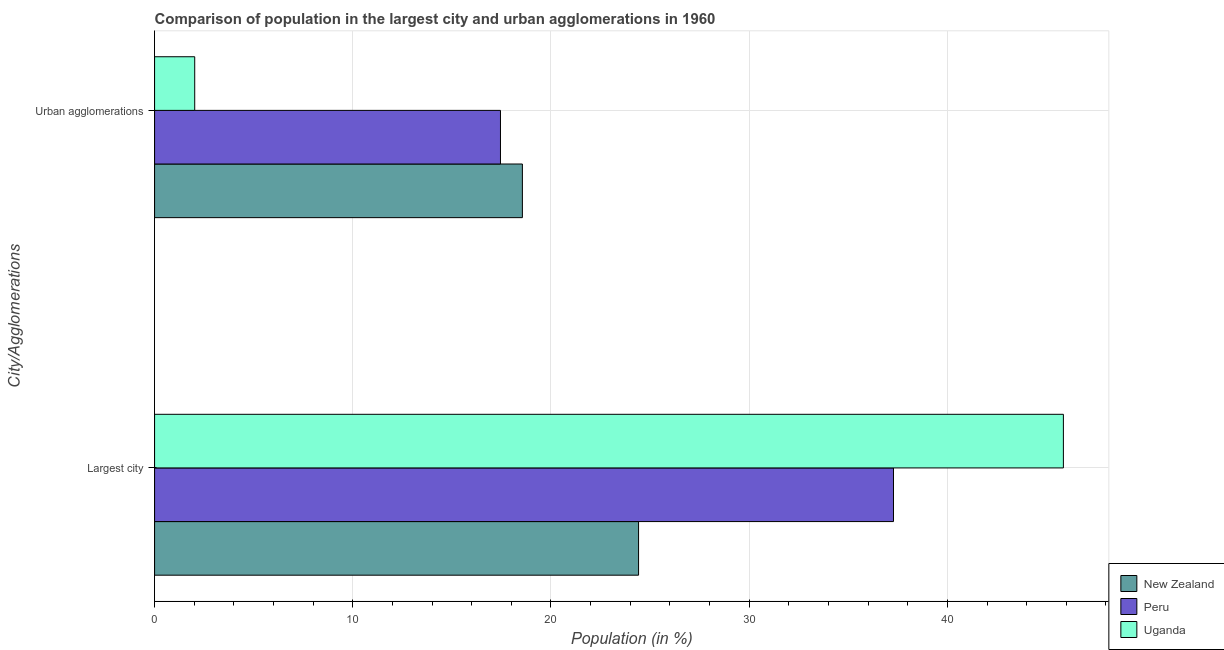How many bars are there on the 2nd tick from the top?
Offer a very short reply. 3. How many bars are there on the 1st tick from the bottom?
Provide a short and direct response. 3. What is the label of the 1st group of bars from the top?
Make the answer very short. Urban agglomerations. What is the population in the largest city in New Zealand?
Ensure brevity in your answer.  24.42. Across all countries, what is the maximum population in urban agglomerations?
Provide a short and direct response. 18.56. Across all countries, what is the minimum population in the largest city?
Provide a succinct answer. 24.42. In which country was the population in urban agglomerations maximum?
Offer a terse response. New Zealand. In which country was the population in the largest city minimum?
Give a very brief answer. New Zealand. What is the total population in the largest city in the graph?
Your answer should be very brief. 107.55. What is the difference between the population in the largest city in New Zealand and that in Uganda?
Keep it short and to the point. -21.43. What is the difference between the population in the largest city in New Zealand and the population in urban agglomerations in Peru?
Keep it short and to the point. 6.97. What is the average population in urban agglomerations per country?
Your answer should be compact. 12.68. What is the difference between the population in urban agglomerations and population in the largest city in New Zealand?
Keep it short and to the point. -5.86. What is the ratio of the population in urban agglomerations in Peru to that in Uganda?
Ensure brevity in your answer.  8.62. In how many countries, is the population in the largest city greater than the average population in the largest city taken over all countries?
Keep it short and to the point. 2. What does the 1st bar from the top in Largest city represents?
Give a very brief answer. Uganda. How many bars are there?
Offer a very short reply. 6. Are all the bars in the graph horizontal?
Keep it short and to the point. Yes. What is the difference between two consecutive major ticks on the X-axis?
Your answer should be compact. 10. Does the graph contain any zero values?
Your answer should be compact. No. Does the graph contain grids?
Provide a short and direct response. Yes. Where does the legend appear in the graph?
Your answer should be compact. Bottom right. What is the title of the graph?
Make the answer very short. Comparison of population in the largest city and urban agglomerations in 1960. What is the label or title of the X-axis?
Your answer should be very brief. Population (in %). What is the label or title of the Y-axis?
Provide a short and direct response. City/Agglomerations. What is the Population (in %) of New Zealand in Largest city?
Provide a succinct answer. 24.42. What is the Population (in %) of Peru in Largest city?
Your answer should be very brief. 37.28. What is the Population (in %) in Uganda in Largest city?
Make the answer very short. 45.85. What is the Population (in %) of New Zealand in Urban agglomerations?
Your response must be concise. 18.56. What is the Population (in %) in Peru in Urban agglomerations?
Your answer should be compact. 17.45. What is the Population (in %) of Uganda in Urban agglomerations?
Give a very brief answer. 2.03. Across all City/Agglomerations, what is the maximum Population (in %) of New Zealand?
Your response must be concise. 24.42. Across all City/Agglomerations, what is the maximum Population (in %) in Peru?
Offer a very short reply. 37.28. Across all City/Agglomerations, what is the maximum Population (in %) of Uganda?
Keep it short and to the point. 45.85. Across all City/Agglomerations, what is the minimum Population (in %) in New Zealand?
Your answer should be very brief. 18.56. Across all City/Agglomerations, what is the minimum Population (in %) in Peru?
Your response must be concise. 17.45. Across all City/Agglomerations, what is the minimum Population (in %) in Uganda?
Your answer should be very brief. 2.03. What is the total Population (in %) in New Zealand in the graph?
Your response must be concise. 42.98. What is the total Population (in %) in Peru in the graph?
Keep it short and to the point. 54.73. What is the total Population (in %) of Uganda in the graph?
Your answer should be compact. 47.88. What is the difference between the Population (in %) of New Zealand in Largest city and that in Urban agglomerations?
Offer a terse response. 5.86. What is the difference between the Population (in %) in Peru in Largest city and that in Urban agglomerations?
Offer a terse response. 19.83. What is the difference between the Population (in %) of Uganda in Largest city and that in Urban agglomerations?
Keep it short and to the point. 43.83. What is the difference between the Population (in %) in New Zealand in Largest city and the Population (in %) in Peru in Urban agglomerations?
Offer a very short reply. 6.97. What is the difference between the Population (in %) of New Zealand in Largest city and the Population (in %) of Uganda in Urban agglomerations?
Offer a very short reply. 22.39. What is the difference between the Population (in %) in Peru in Largest city and the Population (in %) in Uganda in Urban agglomerations?
Offer a terse response. 35.26. What is the average Population (in %) of New Zealand per City/Agglomerations?
Give a very brief answer. 21.49. What is the average Population (in %) of Peru per City/Agglomerations?
Your answer should be compact. 27.37. What is the average Population (in %) of Uganda per City/Agglomerations?
Give a very brief answer. 23.94. What is the difference between the Population (in %) in New Zealand and Population (in %) in Peru in Largest city?
Keep it short and to the point. -12.86. What is the difference between the Population (in %) in New Zealand and Population (in %) in Uganda in Largest city?
Provide a succinct answer. -21.43. What is the difference between the Population (in %) of Peru and Population (in %) of Uganda in Largest city?
Offer a very short reply. -8.57. What is the difference between the Population (in %) of New Zealand and Population (in %) of Peru in Urban agglomerations?
Provide a succinct answer. 1.11. What is the difference between the Population (in %) of New Zealand and Population (in %) of Uganda in Urban agglomerations?
Give a very brief answer. 16.53. What is the difference between the Population (in %) in Peru and Population (in %) in Uganda in Urban agglomerations?
Give a very brief answer. 15.43. What is the ratio of the Population (in %) of New Zealand in Largest city to that in Urban agglomerations?
Your answer should be compact. 1.32. What is the ratio of the Population (in %) in Peru in Largest city to that in Urban agglomerations?
Offer a terse response. 2.14. What is the ratio of the Population (in %) of Uganda in Largest city to that in Urban agglomerations?
Provide a succinct answer. 22.64. What is the difference between the highest and the second highest Population (in %) in New Zealand?
Give a very brief answer. 5.86. What is the difference between the highest and the second highest Population (in %) of Peru?
Ensure brevity in your answer.  19.83. What is the difference between the highest and the second highest Population (in %) of Uganda?
Offer a terse response. 43.83. What is the difference between the highest and the lowest Population (in %) in New Zealand?
Provide a short and direct response. 5.86. What is the difference between the highest and the lowest Population (in %) of Peru?
Your response must be concise. 19.83. What is the difference between the highest and the lowest Population (in %) of Uganda?
Make the answer very short. 43.83. 